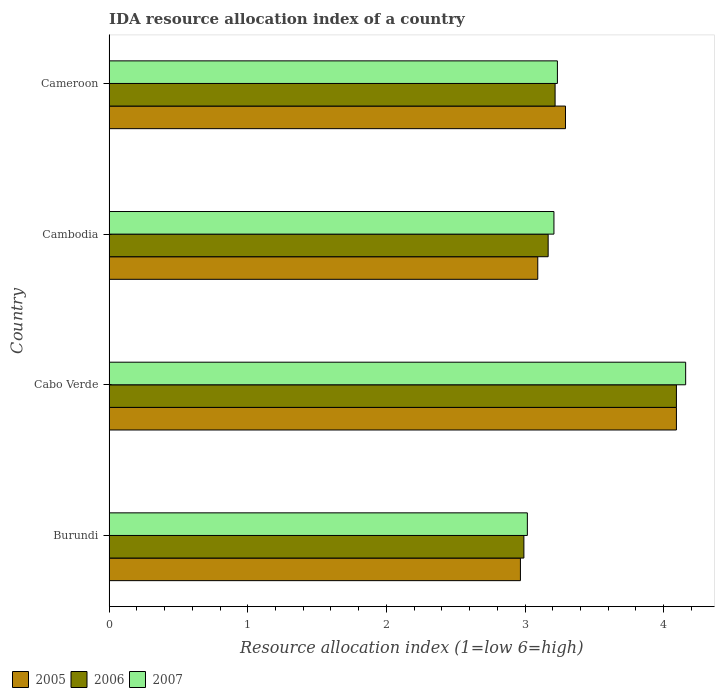How many groups of bars are there?
Your answer should be compact. 4. Are the number of bars per tick equal to the number of legend labels?
Provide a succinct answer. Yes. How many bars are there on the 3rd tick from the top?
Ensure brevity in your answer.  3. How many bars are there on the 4th tick from the bottom?
Keep it short and to the point. 3. What is the label of the 1st group of bars from the top?
Offer a very short reply. Cameroon. What is the IDA resource allocation index in 2007 in Cambodia?
Offer a terse response. 3.21. Across all countries, what is the maximum IDA resource allocation index in 2006?
Provide a short and direct response. 4.09. Across all countries, what is the minimum IDA resource allocation index in 2007?
Provide a succinct answer. 3.02. In which country was the IDA resource allocation index in 2007 maximum?
Make the answer very short. Cabo Verde. In which country was the IDA resource allocation index in 2005 minimum?
Make the answer very short. Burundi. What is the total IDA resource allocation index in 2006 in the graph?
Offer a very short reply. 13.47. What is the difference between the IDA resource allocation index in 2007 in Cambodia and that in Cameroon?
Your answer should be very brief. -0.02. What is the difference between the IDA resource allocation index in 2005 in Cabo Verde and the IDA resource allocation index in 2006 in Cambodia?
Offer a very short reply. 0.92. What is the average IDA resource allocation index in 2006 per country?
Provide a succinct answer. 3.37. What is the difference between the IDA resource allocation index in 2007 and IDA resource allocation index in 2006 in Cambodia?
Your answer should be very brief. 0.04. What is the ratio of the IDA resource allocation index in 2007 in Cabo Verde to that in Cambodia?
Keep it short and to the point. 1.3. Is the IDA resource allocation index in 2006 in Cambodia less than that in Cameroon?
Offer a very short reply. Yes. What is the difference between the highest and the second highest IDA resource allocation index in 2007?
Provide a succinct answer. 0.93. What is the difference between the highest and the lowest IDA resource allocation index in 2007?
Give a very brief answer. 1.14. In how many countries, is the IDA resource allocation index in 2007 greater than the average IDA resource allocation index in 2007 taken over all countries?
Provide a short and direct response. 1. What does the 3rd bar from the bottom in Cambodia represents?
Ensure brevity in your answer.  2007. How many countries are there in the graph?
Make the answer very short. 4. What is the difference between two consecutive major ticks on the X-axis?
Provide a succinct answer. 1. Does the graph contain grids?
Your response must be concise. No. Where does the legend appear in the graph?
Provide a succinct answer. Bottom left. How many legend labels are there?
Your response must be concise. 3. How are the legend labels stacked?
Give a very brief answer. Horizontal. What is the title of the graph?
Keep it short and to the point. IDA resource allocation index of a country. What is the label or title of the X-axis?
Keep it short and to the point. Resource allocation index (1=low 6=high). What is the label or title of the Y-axis?
Your response must be concise. Country. What is the Resource allocation index (1=low 6=high) of 2005 in Burundi?
Give a very brief answer. 2.97. What is the Resource allocation index (1=low 6=high) of 2006 in Burundi?
Make the answer very short. 2.99. What is the Resource allocation index (1=low 6=high) in 2007 in Burundi?
Your response must be concise. 3.02. What is the Resource allocation index (1=low 6=high) in 2005 in Cabo Verde?
Your response must be concise. 4.09. What is the Resource allocation index (1=low 6=high) in 2006 in Cabo Verde?
Your answer should be very brief. 4.09. What is the Resource allocation index (1=low 6=high) in 2007 in Cabo Verde?
Make the answer very short. 4.16. What is the Resource allocation index (1=low 6=high) in 2005 in Cambodia?
Keep it short and to the point. 3.09. What is the Resource allocation index (1=low 6=high) in 2006 in Cambodia?
Your answer should be compact. 3.17. What is the Resource allocation index (1=low 6=high) in 2007 in Cambodia?
Keep it short and to the point. 3.21. What is the Resource allocation index (1=low 6=high) in 2005 in Cameroon?
Make the answer very short. 3.29. What is the Resource allocation index (1=low 6=high) in 2006 in Cameroon?
Provide a succinct answer. 3.22. What is the Resource allocation index (1=low 6=high) in 2007 in Cameroon?
Provide a short and direct response. 3.23. Across all countries, what is the maximum Resource allocation index (1=low 6=high) of 2005?
Your answer should be compact. 4.09. Across all countries, what is the maximum Resource allocation index (1=low 6=high) of 2006?
Your answer should be compact. 4.09. Across all countries, what is the maximum Resource allocation index (1=low 6=high) in 2007?
Offer a terse response. 4.16. Across all countries, what is the minimum Resource allocation index (1=low 6=high) of 2005?
Offer a very short reply. 2.97. Across all countries, what is the minimum Resource allocation index (1=low 6=high) in 2006?
Provide a succinct answer. 2.99. Across all countries, what is the minimum Resource allocation index (1=low 6=high) of 2007?
Provide a succinct answer. 3.02. What is the total Resource allocation index (1=low 6=high) of 2005 in the graph?
Your answer should be very brief. 13.44. What is the total Resource allocation index (1=low 6=high) of 2006 in the graph?
Ensure brevity in your answer.  13.47. What is the total Resource allocation index (1=low 6=high) of 2007 in the graph?
Keep it short and to the point. 13.62. What is the difference between the Resource allocation index (1=low 6=high) in 2005 in Burundi and that in Cabo Verde?
Your answer should be compact. -1.12. What is the difference between the Resource allocation index (1=low 6=high) of 2006 in Burundi and that in Cabo Verde?
Provide a short and direct response. -1.1. What is the difference between the Resource allocation index (1=low 6=high) of 2007 in Burundi and that in Cabo Verde?
Make the answer very short. -1.14. What is the difference between the Resource allocation index (1=low 6=high) of 2005 in Burundi and that in Cambodia?
Your answer should be very brief. -0.12. What is the difference between the Resource allocation index (1=low 6=high) in 2006 in Burundi and that in Cambodia?
Give a very brief answer. -0.17. What is the difference between the Resource allocation index (1=low 6=high) of 2007 in Burundi and that in Cambodia?
Keep it short and to the point. -0.19. What is the difference between the Resource allocation index (1=low 6=high) of 2005 in Burundi and that in Cameroon?
Offer a very short reply. -0.33. What is the difference between the Resource allocation index (1=low 6=high) in 2006 in Burundi and that in Cameroon?
Make the answer very short. -0.23. What is the difference between the Resource allocation index (1=low 6=high) of 2007 in Burundi and that in Cameroon?
Ensure brevity in your answer.  -0.22. What is the difference between the Resource allocation index (1=low 6=high) of 2005 in Cabo Verde and that in Cambodia?
Your response must be concise. 1. What is the difference between the Resource allocation index (1=low 6=high) of 2006 in Cabo Verde and that in Cambodia?
Provide a succinct answer. 0.93. What is the difference between the Resource allocation index (1=low 6=high) in 2007 in Cabo Verde and that in Cambodia?
Provide a short and direct response. 0.95. What is the difference between the Resource allocation index (1=low 6=high) in 2005 in Cabo Verde and that in Cameroon?
Ensure brevity in your answer.  0.8. What is the difference between the Resource allocation index (1=low 6=high) of 2006 in Cabo Verde and that in Cameroon?
Offer a very short reply. 0.88. What is the difference between the Resource allocation index (1=low 6=high) in 2007 in Cabo Verde and that in Cameroon?
Your response must be concise. 0.93. What is the difference between the Resource allocation index (1=low 6=high) in 2005 in Cambodia and that in Cameroon?
Offer a terse response. -0.2. What is the difference between the Resource allocation index (1=low 6=high) in 2007 in Cambodia and that in Cameroon?
Offer a very short reply. -0.03. What is the difference between the Resource allocation index (1=low 6=high) of 2005 in Burundi and the Resource allocation index (1=low 6=high) of 2006 in Cabo Verde?
Your answer should be compact. -1.12. What is the difference between the Resource allocation index (1=low 6=high) in 2005 in Burundi and the Resource allocation index (1=low 6=high) in 2007 in Cabo Verde?
Provide a short and direct response. -1.19. What is the difference between the Resource allocation index (1=low 6=high) of 2006 in Burundi and the Resource allocation index (1=low 6=high) of 2007 in Cabo Verde?
Offer a very short reply. -1.17. What is the difference between the Resource allocation index (1=low 6=high) of 2005 in Burundi and the Resource allocation index (1=low 6=high) of 2007 in Cambodia?
Make the answer very short. -0.24. What is the difference between the Resource allocation index (1=low 6=high) in 2006 in Burundi and the Resource allocation index (1=low 6=high) in 2007 in Cambodia?
Ensure brevity in your answer.  -0.22. What is the difference between the Resource allocation index (1=low 6=high) of 2005 in Burundi and the Resource allocation index (1=low 6=high) of 2007 in Cameroon?
Provide a succinct answer. -0.27. What is the difference between the Resource allocation index (1=low 6=high) of 2006 in Burundi and the Resource allocation index (1=low 6=high) of 2007 in Cameroon?
Keep it short and to the point. -0.24. What is the difference between the Resource allocation index (1=low 6=high) of 2005 in Cabo Verde and the Resource allocation index (1=low 6=high) of 2006 in Cambodia?
Ensure brevity in your answer.  0.93. What is the difference between the Resource allocation index (1=low 6=high) in 2005 in Cabo Verde and the Resource allocation index (1=low 6=high) in 2007 in Cambodia?
Offer a very short reply. 0.88. What is the difference between the Resource allocation index (1=low 6=high) in 2006 in Cabo Verde and the Resource allocation index (1=low 6=high) in 2007 in Cambodia?
Your answer should be compact. 0.88. What is the difference between the Resource allocation index (1=low 6=high) in 2005 in Cabo Verde and the Resource allocation index (1=low 6=high) in 2006 in Cameroon?
Your answer should be compact. 0.88. What is the difference between the Resource allocation index (1=low 6=high) of 2005 in Cabo Verde and the Resource allocation index (1=low 6=high) of 2007 in Cameroon?
Keep it short and to the point. 0.86. What is the difference between the Resource allocation index (1=low 6=high) in 2006 in Cabo Verde and the Resource allocation index (1=low 6=high) in 2007 in Cameroon?
Your response must be concise. 0.86. What is the difference between the Resource allocation index (1=low 6=high) in 2005 in Cambodia and the Resource allocation index (1=low 6=high) in 2006 in Cameroon?
Offer a terse response. -0.12. What is the difference between the Resource allocation index (1=low 6=high) of 2005 in Cambodia and the Resource allocation index (1=low 6=high) of 2007 in Cameroon?
Your response must be concise. -0.14. What is the difference between the Resource allocation index (1=low 6=high) of 2006 in Cambodia and the Resource allocation index (1=low 6=high) of 2007 in Cameroon?
Offer a very short reply. -0.07. What is the average Resource allocation index (1=low 6=high) in 2005 per country?
Keep it short and to the point. 3.36. What is the average Resource allocation index (1=low 6=high) in 2006 per country?
Your answer should be very brief. 3.37. What is the average Resource allocation index (1=low 6=high) of 2007 per country?
Keep it short and to the point. 3.4. What is the difference between the Resource allocation index (1=low 6=high) in 2005 and Resource allocation index (1=low 6=high) in 2006 in Burundi?
Ensure brevity in your answer.  -0.03. What is the difference between the Resource allocation index (1=low 6=high) of 2005 and Resource allocation index (1=low 6=high) of 2007 in Burundi?
Your answer should be compact. -0.05. What is the difference between the Resource allocation index (1=low 6=high) of 2006 and Resource allocation index (1=low 6=high) of 2007 in Burundi?
Offer a very short reply. -0.03. What is the difference between the Resource allocation index (1=low 6=high) of 2005 and Resource allocation index (1=low 6=high) of 2006 in Cabo Verde?
Your answer should be compact. 0. What is the difference between the Resource allocation index (1=low 6=high) in 2005 and Resource allocation index (1=low 6=high) in 2007 in Cabo Verde?
Keep it short and to the point. -0.07. What is the difference between the Resource allocation index (1=low 6=high) of 2006 and Resource allocation index (1=low 6=high) of 2007 in Cabo Verde?
Offer a terse response. -0.07. What is the difference between the Resource allocation index (1=low 6=high) in 2005 and Resource allocation index (1=low 6=high) in 2006 in Cambodia?
Keep it short and to the point. -0.07. What is the difference between the Resource allocation index (1=low 6=high) of 2005 and Resource allocation index (1=low 6=high) of 2007 in Cambodia?
Keep it short and to the point. -0.12. What is the difference between the Resource allocation index (1=low 6=high) of 2006 and Resource allocation index (1=low 6=high) of 2007 in Cambodia?
Provide a short and direct response. -0.04. What is the difference between the Resource allocation index (1=low 6=high) of 2005 and Resource allocation index (1=low 6=high) of 2006 in Cameroon?
Offer a terse response. 0.07. What is the difference between the Resource allocation index (1=low 6=high) in 2005 and Resource allocation index (1=low 6=high) in 2007 in Cameroon?
Your answer should be compact. 0.06. What is the difference between the Resource allocation index (1=low 6=high) of 2006 and Resource allocation index (1=low 6=high) of 2007 in Cameroon?
Provide a short and direct response. -0.02. What is the ratio of the Resource allocation index (1=low 6=high) in 2005 in Burundi to that in Cabo Verde?
Offer a very short reply. 0.73. What is the ratio of the Resource allocation index (1=low 6=high) in 2006 in Burundi to that in Cabo Verde?
Give a very brief answer. 0.73. What is the ratio of the Resource allocation index (1=low 6=high) of 2007 in Burundi to that in Cabo Verde?
Your response must be concise. 0.73. What is the ratio of the Resource allocation index (1=low 6=high) in 2005 in Burundi to that in Cambodia?
Provide a succinct answer. 0.96. What is the ratio of the Resource allocation index (1=low 6=high) of 2006 in Burundi to that in Cambodia?
Offer a very short reply. 0.94. What is the ratio of the Resource allocation index (1=low 6=high) of 2007 in Burundi to that in Cambodia?
Make the answer very short. 0.94. What is the ratio of the Resource allocation index (1=low 6=high) in 2005 in Burundi to that in Cameroon?
Keep it short and to the point. 0.9. What is the ratio of the Resource allocation index (1=low 6=high) of 2006 in Burundi to that in Cameroon?
Your answer should be compact. 0.93. What is the ratio of the Resource allocation index (1=low 6=high) of 2007 in Burundi to that in Cameroon?
Provide a succinct answer. 0.93. What is the ratio of the Resource allocation index (1=low 6=high) of 2005 in Cabo Verde to that in Cambodia?
Provide a short and direct response. 1.32. What is the ratio of the Resource allocation index (1=low 6=high) in 2006 in Cabo Verde to that in Cambodia?
Ensure brevity in your answer.  1.29. What is the ratio of the Resource allocation index (1=low 6=high) in 2007 in Cabo Verde to that in Cambodia?
Provide a succinct answer. 1.3. What is the ratio of the Resource allocation index (1=low 6=high) in 2005 in Cabo Verde to that in Cameroon?
Provide a short and direct response. 1.24. What is the ratio of the Resource allocation index (1=low 6=high) of 2006 in Cabo Verde to that in Cameroon?
Your answer should be very brief. 1.27. What is the ratio of the Resource allocation index (1=low 6=high) of 2007 in Cabo Verde to that in Cameroon?
Provide a succinct answer. 1.29. What is the ratio of the Resource allocation index (1=low 6=high) of 2005 in Cambodia to that in Cameroon?
Your answer should be compact. 0.94. What is the ratio of the Resource allocation index (1=low 6=high) of 2006 in Cambodia to that in Cameroon?
Keep it short and to the point. 0.98. What is the ratio of the Resource allocation index (1=low 6=high) of 2007 in Cambodia to that in Cameroon?
Give a very brief answer. 0.99. What is the difference between the highest and the second highest Resource allocation index (1=low 6=high) in 2006?
Give a very brief answer. 0.88. What is the difference between the highest and the second highest Resource allocation index (1=low 6=high) of 2007?
Offer a terse response. 0.93. What is the difference between the highest and the lowest Resource allocation index (1=low 6=high) in 2005?
Your answer should be compact. 1.12. What is the difference between the highest and the lowest Resource allocation index (1=low 6=high) of 2007?
Ensure brevity in your answer.  1.14. 